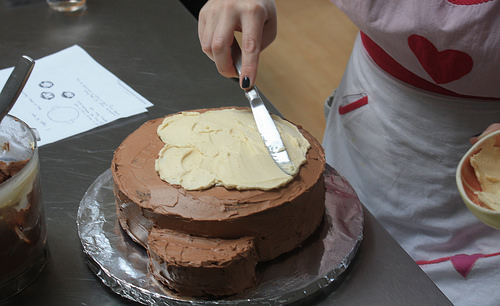<image>
Can you confirm if the knife is to the left of the cake? No. The knife is not to the left of the cake. From this viewpoint, they have a different horizontal relationship. Is the cake next to the paper? Yes. The cake is positioned adjacent to the paper, located nearby in the same general area. 